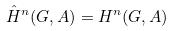Convert formula to latex. <formula><loc_0><loc_0><loc_500><loc_500>\hat { H } ^ { n } ( G , A ) = H ^ { n } ( G , A )</formula> 